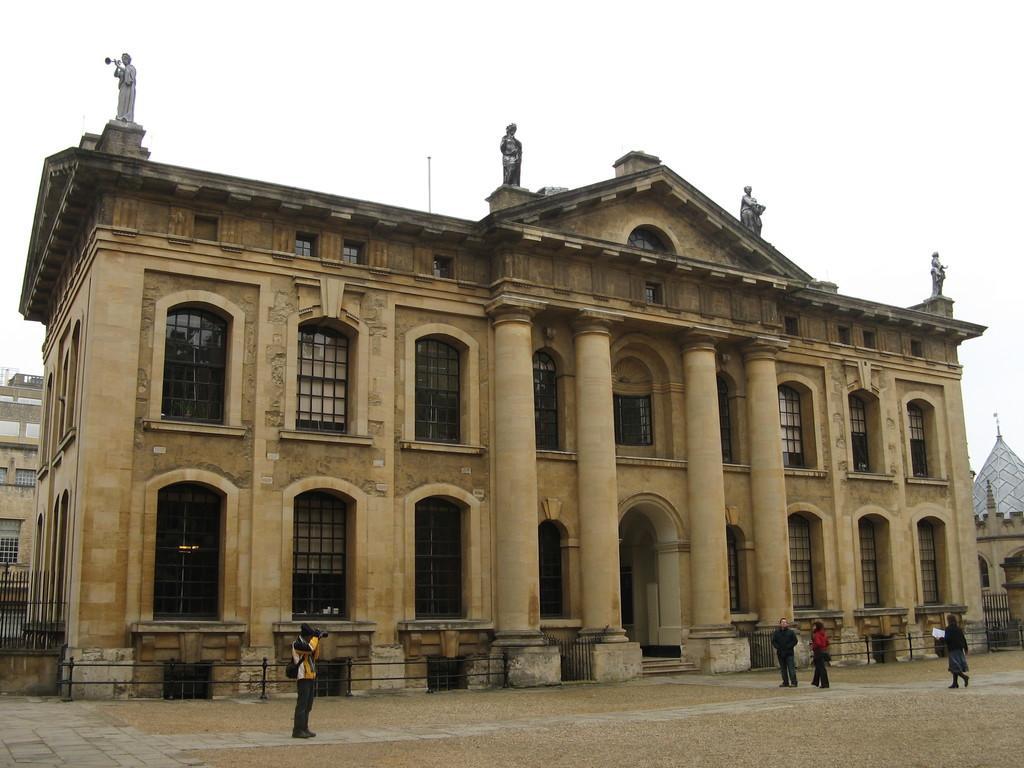Please provide a concise description of this image. In this image, there are buildings. I can see the sculptures on top of a building. In front of the building, there are four persons standing. In the background there is the sky. 